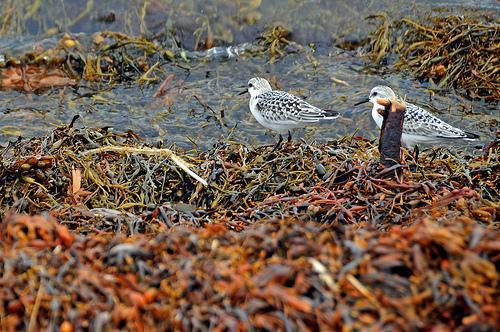How many birds do you see?
Give a very brief answer. 2. 